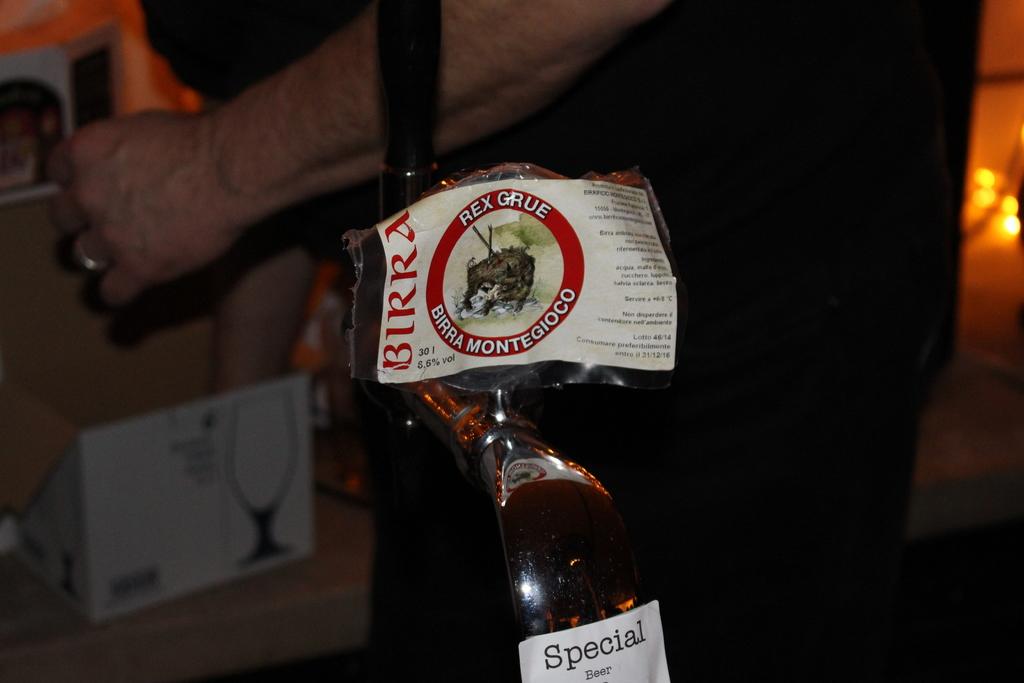Is this special beer?
Ensure brevity in your answer.  Yes. 